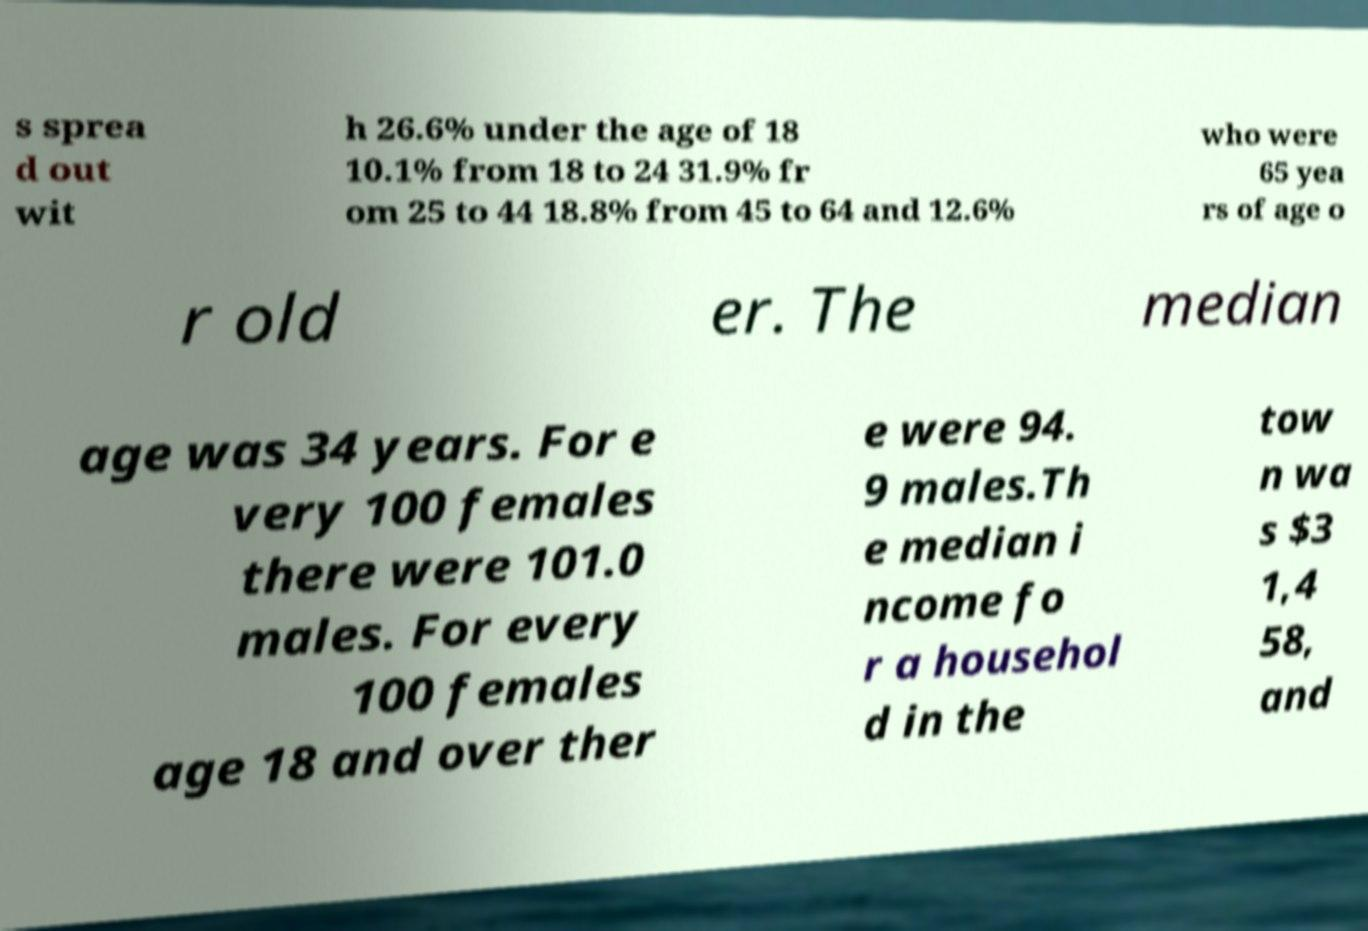There's text embedded in this image that I need extracted. Can you transcribe it verbatim? s sprea d out wit h 26.6% under the age of 18 10.1% from 18 to 24 31.9% fr om 25 to 44 18.8% from 45 to 64 and 12.6% who were 65 yea rs of age o r old er. The median age was 34 years. For e very 100 females there were 101.0 males. For every 100 females age 18 and over ther e were 94. 9 males.Th e median i ncome fo r a househol d in the tow n wa s $3 1,4 58, and 